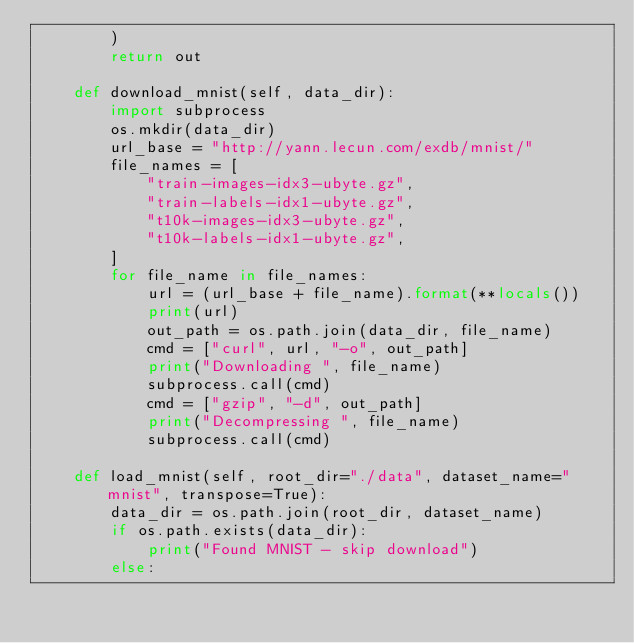<code> <loc_0><loc_0><loc_500><loc_500><_Python_>        )
        return out

    def download_mnist(self, data_dir):
        import subprocess
        os.mkdir(data_dir)
        url_base = "http://yann.lecun.com/exdb/mnist/"
        file_names = [
            "train-images-idx3-ubyte.gz",
            "train-labels-idx1-ubyte.gz",
            "t10k-images-idx3-ubyte.gz",
            "t10k-labels-idx1-ubyte.gz",
        ]
        for file_name in file_names:
            url = (url_base + file_name).format(**locals())
            print(url)
            out_path = os.path.join(data_dir, file_name)
            cmd = ["curl", url, "-o", out_path]
            print("Downloading ", file_name)
            subprocess.call(cmd)
            cmd = ["gzip", "-d", out_path]
            print("Decompressing ", file_name)
            subprocess.call(cmd)

    def load_mnist(self, root_dir="./data", dataset_name="mnist", transpose=True):
        data_dir = os.path.join(root_dir, dataset_name)
        if os.path.exists(data_dir):
            print("Found MNIST - skip download")
        else:</code> 